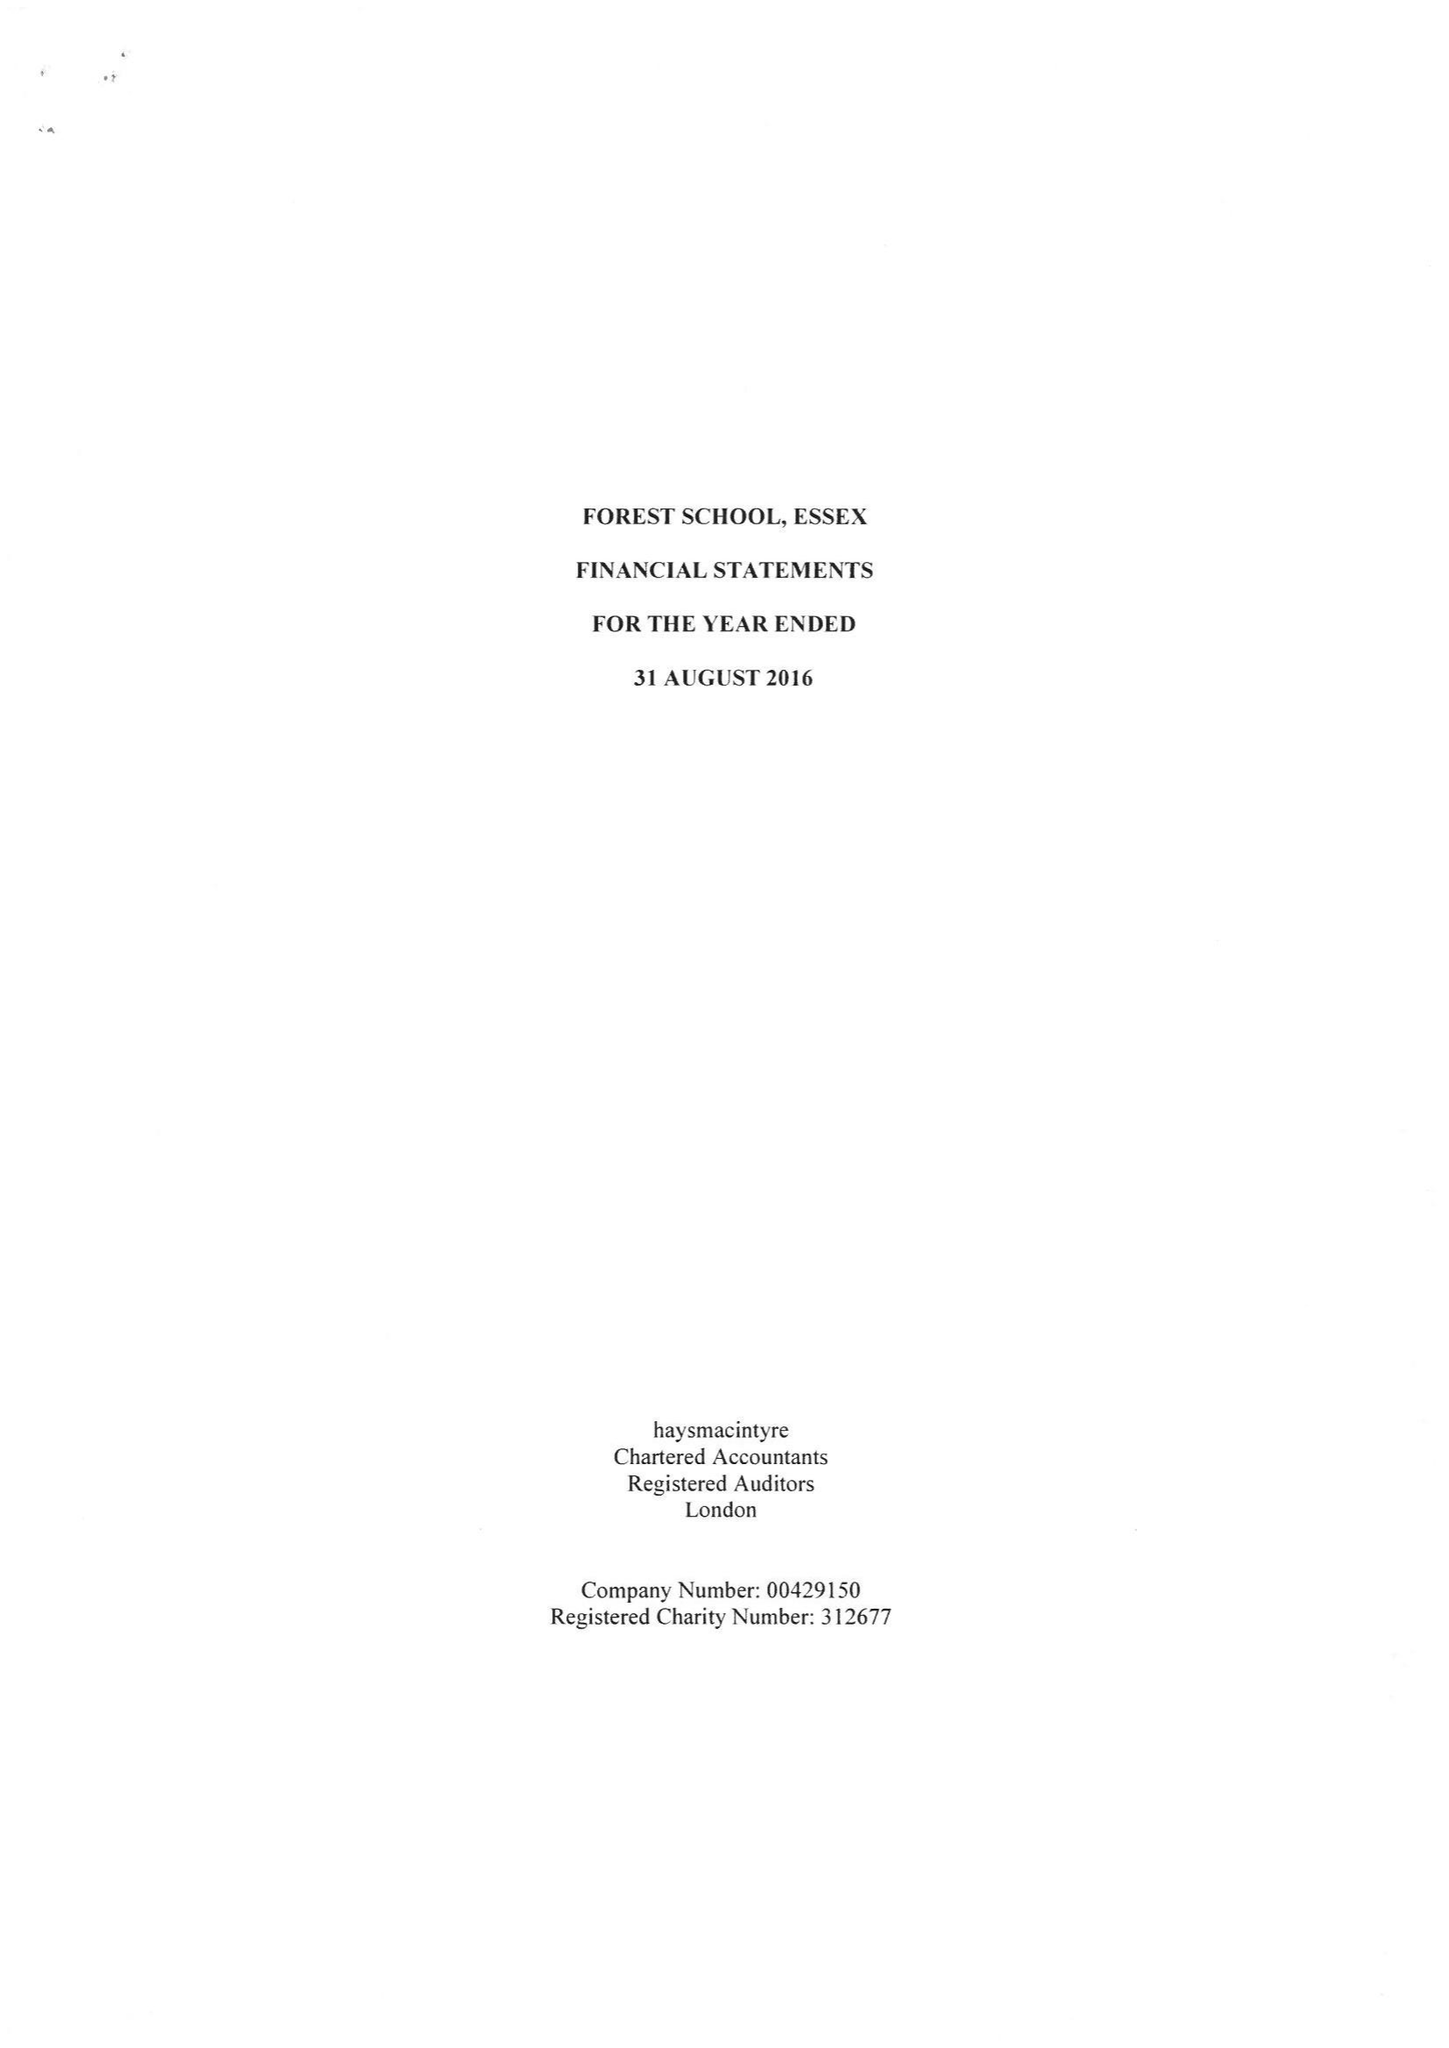What is the value for the report_date?
Answer the question using a single word or phrase. 2016-08-31 